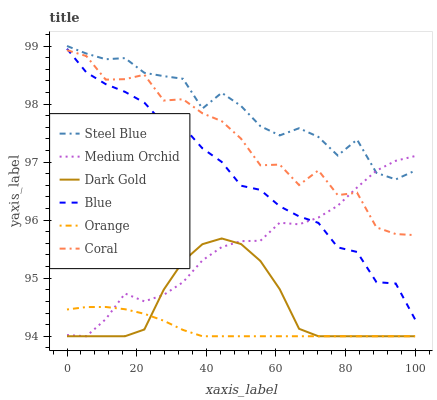Does Dark Gold have the minimum area under the curve?
Answer yes or no. No. Does Dark Gold have the maximum area under the curve?
Answer yes or no. No. Is Dark Gold the smoothest?
Answer yes or no. No. Is Dark Gold the roughest?
Answer yes or no. No. Does Coral have the lowest value?
Answer yes or no. No. Does Dark Gold have the highest value?
Answer yes or no. No. Is Dark Gold less than Steel Blue?
Answer yes or no. Yes. Is Coral greater than Dark Gold?
Answer yes or no. Yes. Does Dark Gold intersect Steel Blue?
Answer yes or no. No. 